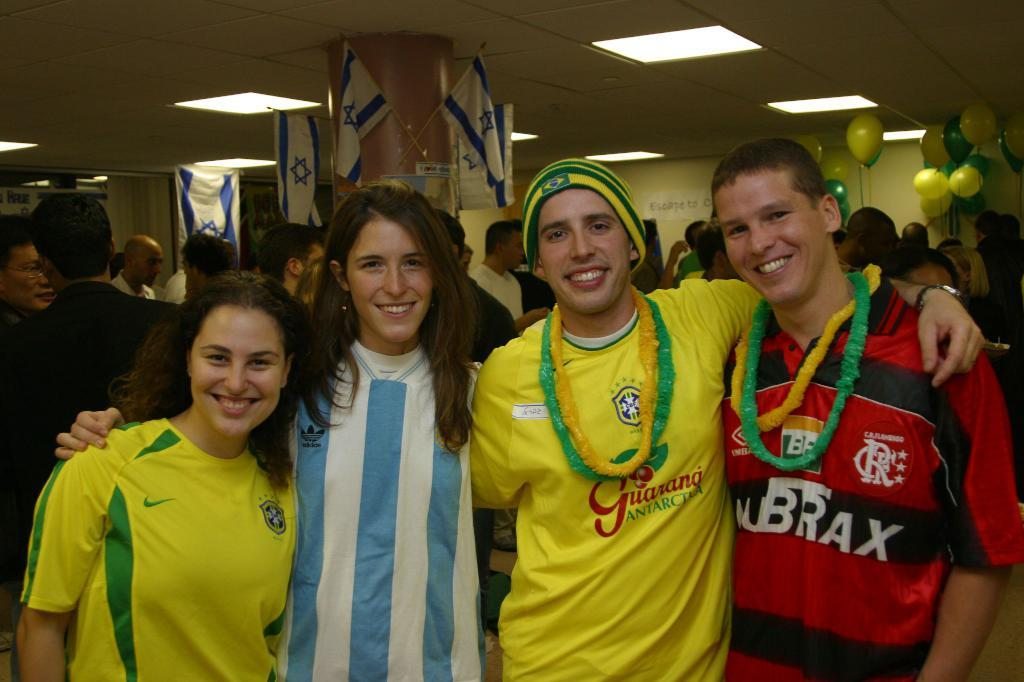How many people are in the group visible in the image? There is a group of people in the image, but the exact number cannot be determined from the provided facts. What is located behind the group of people? There is a pillar behind the people in the image. What can be seen in the background of the image? In the background of the image, there are flags and balloons. What is written or displayed on the wall in the image? There is a banner on the wall in the image. What type of lighting is visible at the top of the image? Ceiling lights are visible at the top of the image. Where is the mailbox located in the image? There is no mailbox present in the image. What type of structure is being carried by the people in the image? There is no structure being carried by the people in the image. 